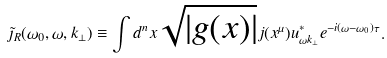Convert formula to latex. <formula><loc_0><loc_0><loc_500><loc_500>\tilde { \jmath } _ { R } ( \omega _ { 0 } , \omega , k _ { \bot } ) \equiv \int d ^ { n } x \sqrt { | g ( x ) | } j ( x ^ { \mu } ) u ^ { * } _ { \omega { k } _ { \bot } } e ^ { - i ( \omega - \omega _ { 0 } ) \tau } .</formula> 